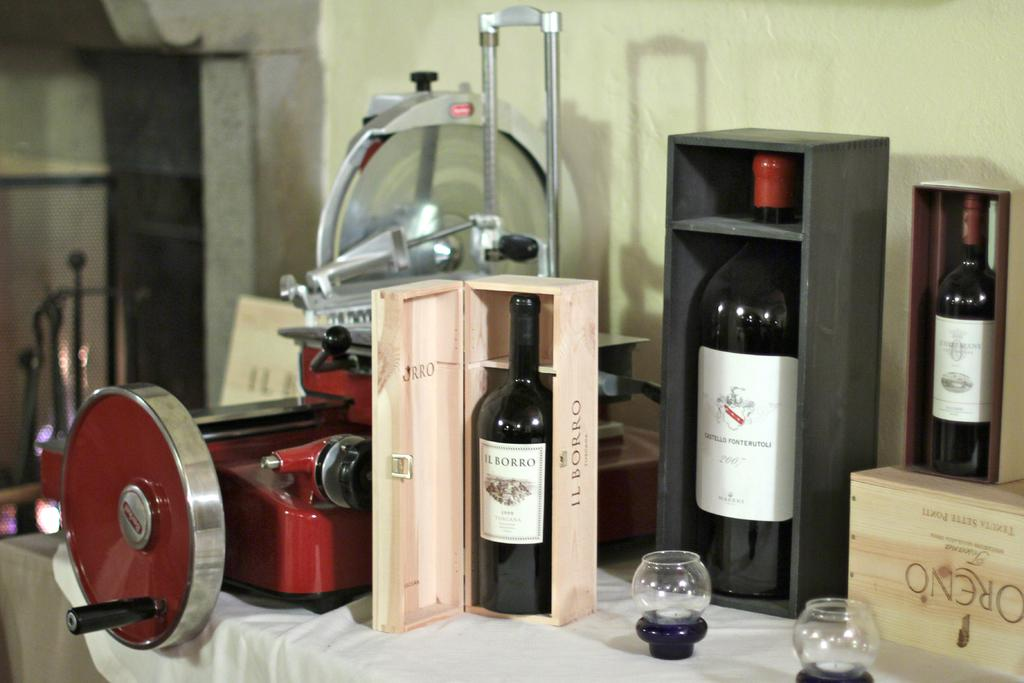<image>
Present a compact description of the photo's key features. A bottle of Il Borro sits in a wooden crate near a red machine. 